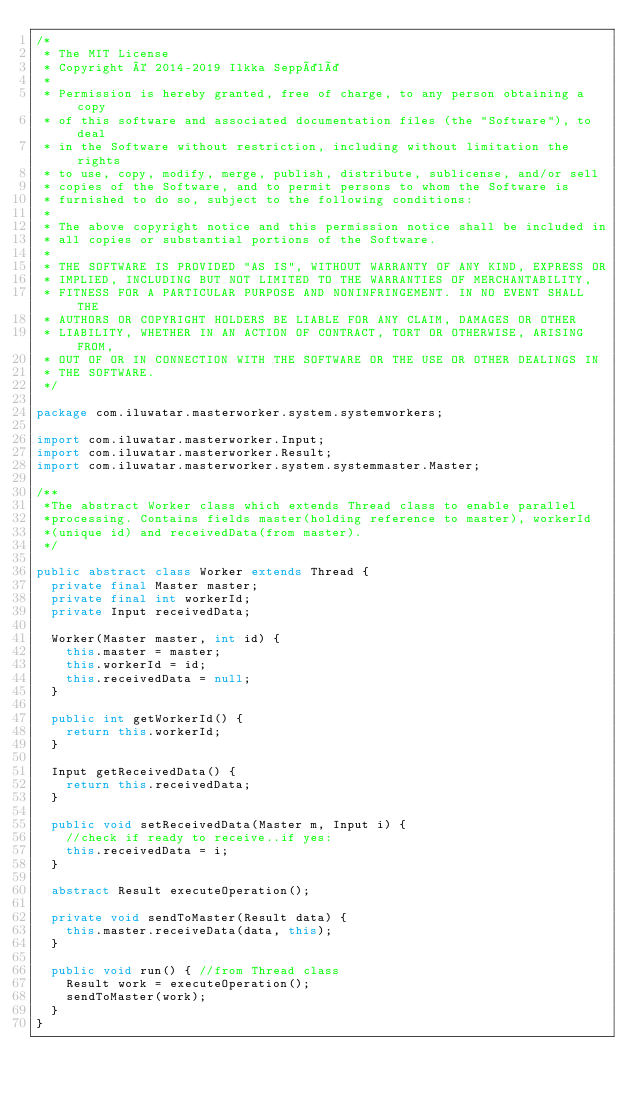<code> <loc_0><loc_0><loc_500><loc_500><_Java_>/*
 * The MIT License
 * Copyright © 2014-2019 Ilkka Seppälä
 *
 * Permission is hereby granted, free of charge, to any person obtaining a copy
 * of this software and associated documentation files (the "Software"), to deal
 * in the Software without restriction, including without limitation the rights
 * to use, copy, modify, merge, publish, distribute, sublicense, and/or sell
 * copies of the Software, and to permit persons to whom the Software is
 * furnished to do so, subject to the following conditions:
 *
 * The above copyright notice and this permission notice shall be included in
 * all copies or substantial portions of the Software.
 *
 * THE SOFTWARE IS PROVIDED "AS IS", WITHOUT WARRANTY OF ANY KIND, EXPRESS OR
 * IMPLIED, INCLUDING BUT NOT LIMITED TO THE WARRANTIES OF MERCHANTABILITY,
 * FITNESS FOR A PARTICULAR PURPOSE AND NONINFRINGEMENT. IN NO EVENT SHALL THE
 * AUTHORS OR COPYRIGHT HOLDERS BE LIABLE FOR ANY CLAIM, DAMAGES OR OTHER
 * LIABILITY, WHETHER IN AN ACTION OF CONTRACT, TORT OR OTHERWISE, ARISING FROM,
 * OUT OF OR IN CONNECTION WITH THE SOFTWARE OR THE USE OR OTHER DEALINGS IN
 * THE SOFTWARE.
 */

package com.iluwatar.masterworker.system.systemworkers;

import com.iluwatar.masterworker.Input;
import com.iluwatar.masterworker.Result;
import com.iluwatar.masterworker.system.systemmaster.Master;

/**
 *The abstract Worker class which extends Thread class to enable parallel
 *processing. Contains fields master(holding reference to master), workerId
 *(unique id) and receivedData(from master).
 */

public abstract class Worker extends Thread {
  private final Master master;
  private final int workerId;
  private Input receivedData;

  Worker(Master master, int id) {
    this.master = master;
    this.workerId = id;
    this.receivedData = null;
  }

  public int getWorkerId() {
    return this.workerId;
  }

  Input getReceivedData() {
    return this.receivedData;
  }

  public void setReceivedData(Master m, Input i) {
    //check if ready to receive..if yes:
    this.receivedData = i;
  }

  abstract Result executeOperation();

  private void sendToMaster(Result data) {
    this.master.receiveData(data, this);
  } 

  public void run() { //from Thread class
    Result work = executeOperation();
    sendToMaster(work);
  }
}
</code> 